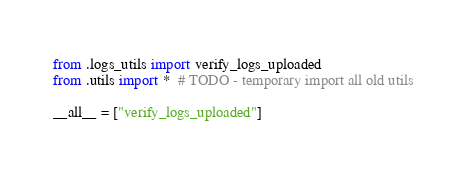Convert code to text. <code><loc_0><loc_0><loc_500><loc_500><_Python_>from .logs_utils import verify_logs_uploaded
from .utils import *  # TODO - temporary import all old utils

__all__ = ["verify_logs_uploaded"]
</code> 